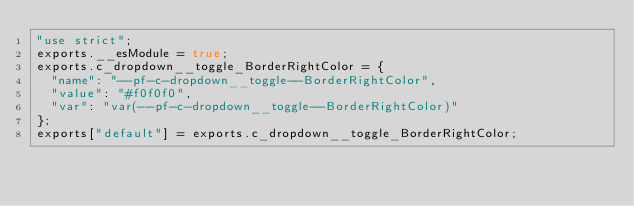<code> <loc_0><loc_0><loc_500><loc_500><_JavaScript_>"use strict";
exports.__esModule = true;
exports.c_dropdown__toggle_BorderRightColor = {
  "name": "--pf-c-dropdown__toggle--BorderRightColor",
  "value": "#f0f0f0",
  "var": "var(--pf-c-dropdown__toggle--BorderRightColor)"
};
exports["default"] = exports.c_dropdown__toggle_BorderRightColor;</code> 